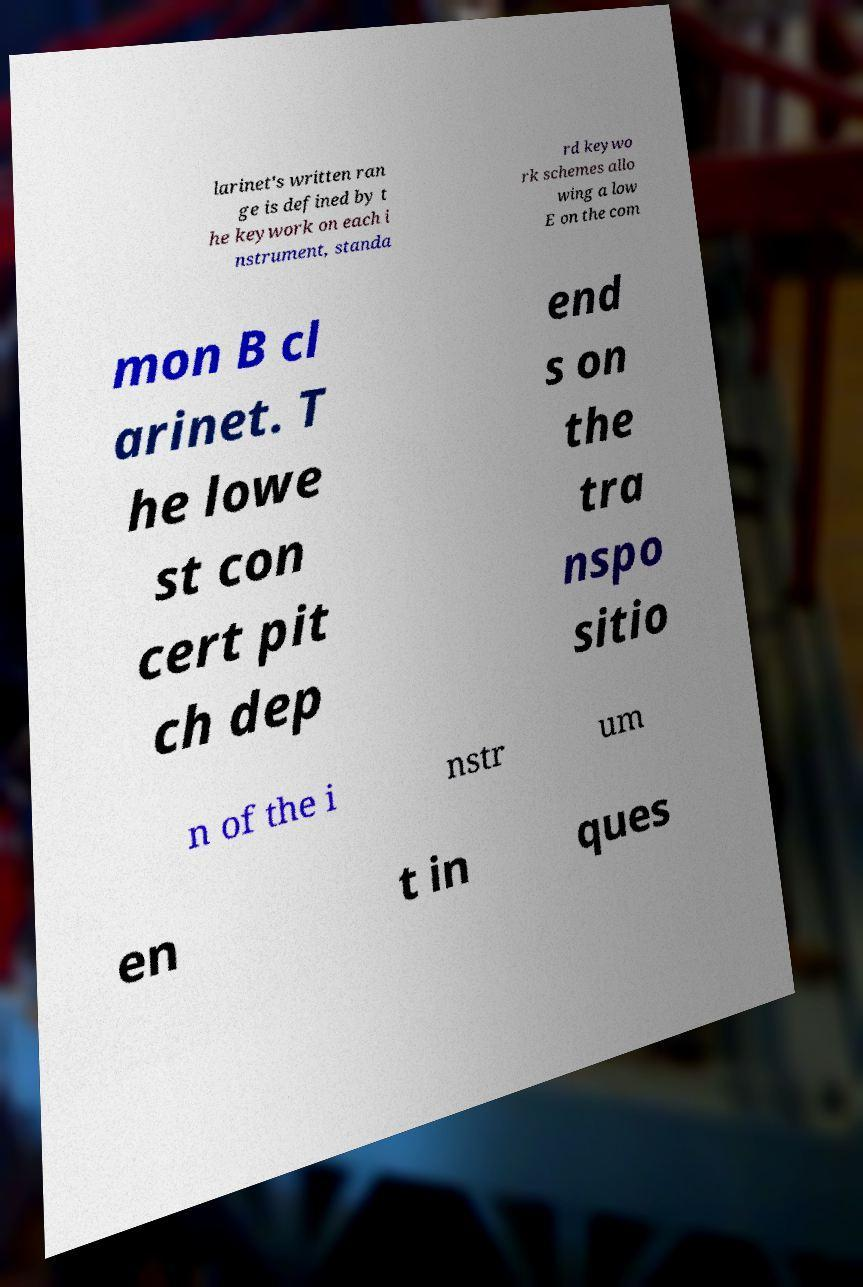Can you accurately transcribe the text from the provided image for me? larinet's written ran ge is defined by t he keywork on each i nstrument, standa rd keywo rk schemes allo wing a low E on the com mon B cl arinet. T he lowe st con cert pit ch dep end s on the tra nspo sitio n of the i nstr um en t in ques 